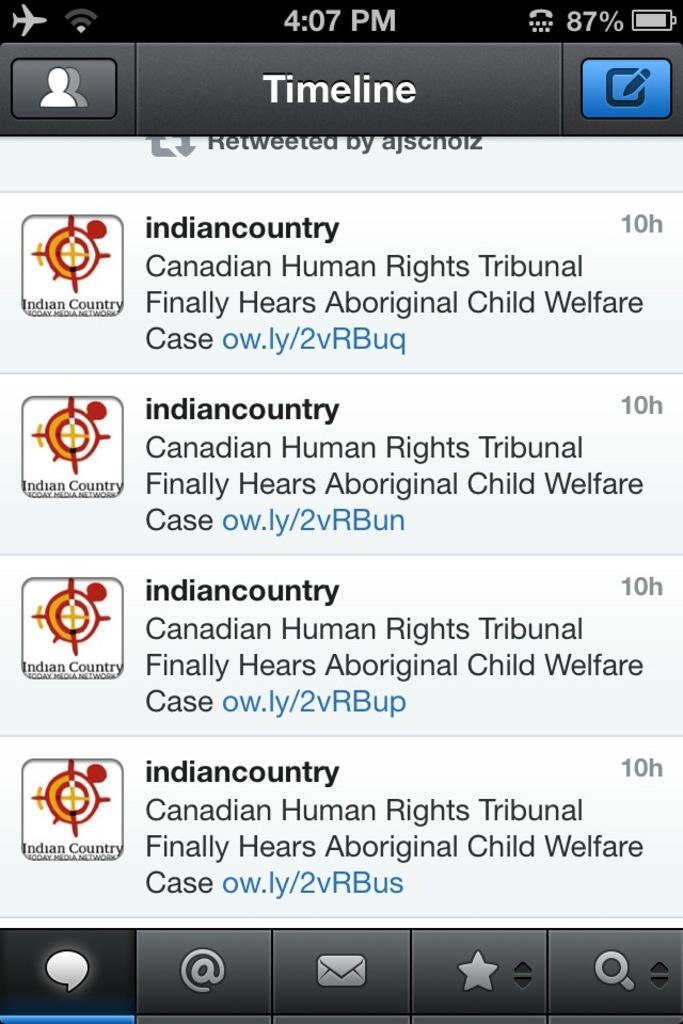Provide a one-sentence caption for the provided image. The ads on the phone are from Indian Country. 